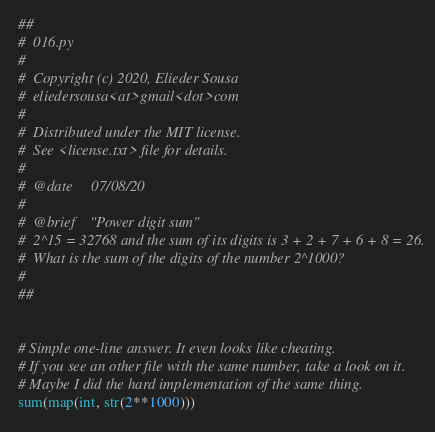Convert code to text. <code><loc_0><loc_0><loc_500><loc_500><_Python_>## 
#  016.py
#  
#  Copyright (c) 2020, Elieder Sousa
#  eliedersousa<at>gmail<dot>com
#  
#  Distributed under the MIT license. 
#  See <license.txt> file for details.
#  
#  @date     07/08/20
#  
#  @brief    "Power digit sum"
#  2^15 = 32768 and the sum of its digits is 3 + 2 + 7 + 6 + 8 = 26.
#  What is the sum of the digits of the number 2^1000?
#
##


# Simple one-line answer. It even looks like cheating.
# If you see an other file with the same number, take a look on it.
# Maybe I did the hard implementation of the same thing.
sum(map(int, str(2**1000)))</code> 